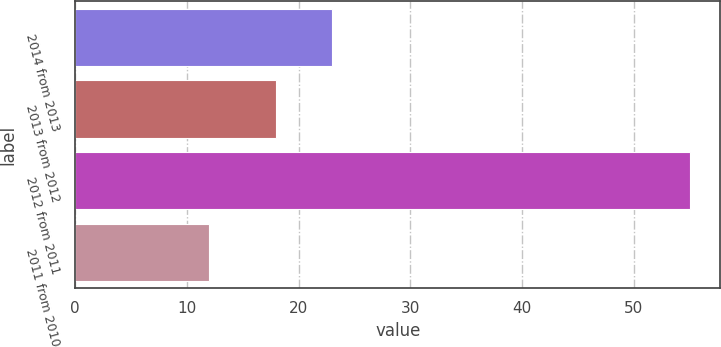<chart> <loc_0><loc_0><loc_500><loc_500><bar_chart><fcel>2014 from 2013<fcel>2013 from 2012<fcel>2012 from 2011<fcel>2011 from 2010<nl><fcel>23<fcel>18<fcel>55<fcel>12<nl></chart> 